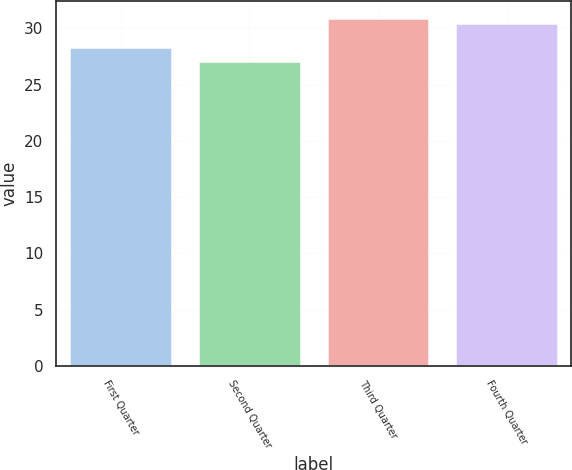Convert chart. <chart><loc_0><loc_0><loc_500><loc_500><bar_chart><fcel>First Quarter<fcel>Second Quarter<fcel>Third Quarter<fcel>Fourth Quarter<nl><fcel>28.35<fcel>27.1<fcel>30.91<fcel>30.5<nl></chart> 